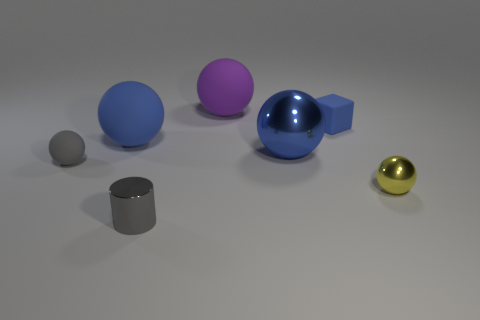Is there any other thing that has the same shape as the purple object?
Offer a very short reply. Yes. What number of tiny things are on the right side of the big shiny thing and to the left of the yellow metal thing?
Give a very brief answer. 1. What is the material of the cylinder?
Provide a short and direct response. Metal. Are there the same number of small cylinders to the left of the big blue matte sphere and purple spheres?
Provide a short and direct response. No. How many purple things have the same shape as the blue shiny object?
Ensure brevity in your answer.  1. Do the blue shiny thing and the big blue matte object have the same shape?
Offer a terse response. Yes. What number of things are objects that are left of the blue cube or small blue rubber things?
Your response must be concise. 6. There is a large matte object on the left side of the shiny thing that is on the left side of the large rubber sphere that is right of the gray metal cylinder; what shape is it?
Make the answer very short. Sphere. There is a tiny gray object that is the same material as the yellow ball; what shape is it?
Your answer should be compact. Cylinder. What size is the yellow thing?
Your answer should be compact. Small. 